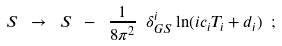<formula> <loc_0><loc_0><loc_500><loc_500>S \ \rightarrow \ S \ - \ \frac { 1 } { 8 \pi ^ { 2 } } \ \delta ^ { i } _ { G S } \ln ( i c _ { i } T _ { i } + d _ { i } ) \ ;</formula> 